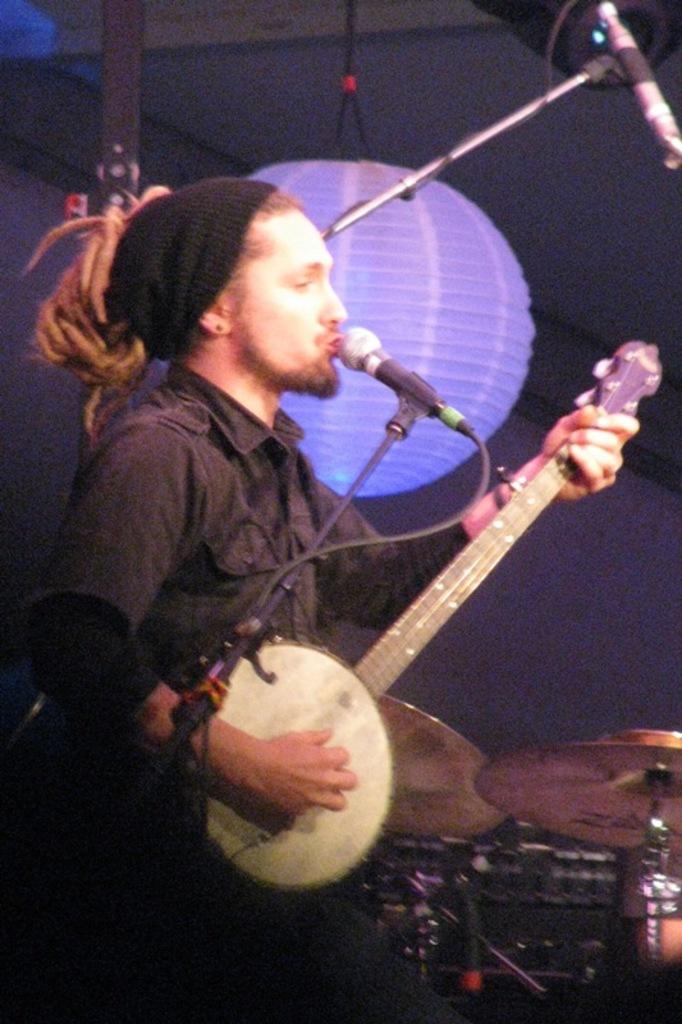What is the person in the image doing? The person in the image is playing a musical instrument. What is in front of the person? There is a microphone (mic) in front of the person. What other musical instruments are visible in the image? There are other musical instruments beside the person. Can you describe any other objects in the image? There is a lamp hanging in the image. Where is the farm located in the image? There is no farm present in the image. What type of treatment is being administered to the person in the image? There is no treatment being administered to the person in the image; they are playing a musical instrument. 